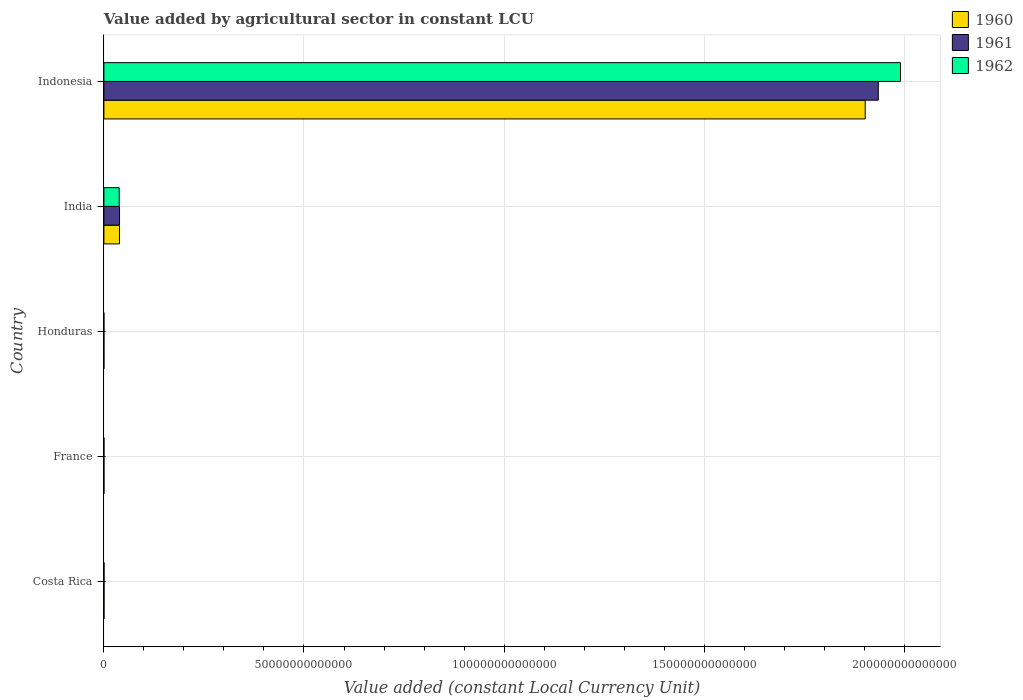How many different coloured bars are there?
Keep it short and to the point. 3. How many groups of bars are there?
Offer a very short reply. 5. Are the number of bars on each tick of the Y-axis equal?
Your response must be concise. Yes. How many bars are there on the 2nd tick from the bottom?
Provide a succinct answer. 3. What is the value added by agricultural sector in 1962 in Honduras?
Provide a short and direct response. 4.96e+09. Across all countries, what is the maximum value added by agricultural sector in 1962?
Keep it short and to the point. 1.99e+14. Across all countries, what is the minimum value added by agricultural sector in 1962?
Your answer should be compact. 4.96e+09. In which country was the value added by agricultural sector in 1960 maximum?
Give a very brief answer. Indonesia. In which country was the value added by agricultural sector in 1961 minimum?
Offer a terse response. Honduras. What is the total value added by agricultural sector in 1960 in the graph?
Your answer should be compact. 1.94e+14. What is the difference between the value added by agricultural sector in 1960 in Costa Rica and that in France?
Provide a succinct answer. 1.92e+1. What is the difference between the value added by agricultural sector in 1961 in India and the value added by agricultural sector in 1960 in France?
Offer a terse response. 3.89e+12. What is the average value added by agricultural sector in 1962 per country?
Give a very brief answer. 4.06e+13. What is the difference between the value added by agricultural sector in 1961 and value added by agricultural sector in 1962 in Honduras?
Offer a very short reply. -2.25e+08. In how many countries, is the value added by agricultural sector in 1960 greater than 50000000000000 LCU?
Ensure brevity in your answer.  1. What is the ratio of the value added by agricultural sector in 1961 in Costa Rica to that in Indonesia?
Offer a terse response. 0. Is the difference between the value added by agricultural sector in 1961 in France and Indonesia greater than the difference between the value added by agricultural sector in 1962 in France and Indonesia?
Make the answer very short. Yes. What is the difference between the highest and the second highest value added by agricultural sector in 1962?
Your response must be concise. 1.95e+14. What is the difference between the highest and the lowest value added by agricultural sector in 1962?
Ensure brevity in your answer.  1.99e+14. Is it the case that in every country, the sum of the value added by agricultural sector in 1961 and value added by agricultural sector in 1962 is greater than the value added by agricultural sector in 1960?
Your response must be concise. Yes. How many bars are there?
Your answer should be very brief. 15. Are all the bars in the graph horizontal?
Ensure brevity in your answer.  Yes. What is the difference between two consecutive major ticks on the X-axis?
Offer a very short reply. 5.00e+13. Does the graph contain any zero values?
Provide a succinct answer. No. Does the graph contain grids?
Your answer should be compact. Yes. Where does the legend appear in the graph?
Provide a succinct answer. Top right. How many legend labels are there?
Provide a succinct answer. 3. What is the title of the graph?
Your answer should be compact. Value added by agricultural sector in constant LCU. Does "1998" appear as one of the legend labels in the graph?
Your answer should be compact. No. What is the label or title of the X-axis?
Ensure brevity in your answer.  Value added (constant Local Currency Unit). What is the label or title of the Y-axis?
Keep it short and to the point. Country. What is the Value added (constant Local Currency Unit) of 1960 in Costa Rica?
Your answer should be very brief. 3.24e+1. What is the Value added (constant Local Currency Unit) in 1961 in Costa Rica?
Your answer should be very brief. 3.36e+1. What is the Value added (constant Local Currency Unit) of 1962 in Costa Rica?
Offer a terse response. 3.57e+1. What is the Value added (constant Local Currency Unit) of 1960 in France?
Provide a succinct answer. 1.32e+1. What is the Value added (constant Local Currency Unit) in 1961 in France?
Your response must be concise. 1.25e+1. What is the Value added (constant Local Currency Unit) in 1962 in France?
Offer a very short reply. 1.36e+1. What is the Value added (constant Local Currency Unit) in 1960 in Honduras?
Provide a succinct answer. 4.44e+09. What is the Value added (constant Local Currency Unit) in 1961 in Honduras?
Ensure brevity in your answer.  4.73e+09. What is the Value added (constant Local Currency Unit) in 1962 in Honduras?
Ensure brevity in your answer.  4.96e+09. What is the Value added (constant Local Currency Unit) of 1960 in India?
Give a very brief answer. 3.90e+12. What is the Value added (constant Local Currency Unit) of 1961 in India?
Your answer should be compact. 3.91e+12. What is the Value added (constant Local Currency Unit) of 1962 in India?
Offer a very short reply. 3.83e+12. What is the Value added (constant Local Currency Unit) of 1960 in Indonesia?
Keep it short and to the point. 1.90e+14. What is the Value added (constant Local Currency Unit) in 1961 in Indonesia?
Ensure brevity in your answer.  1.94e+14. What is the Value added (constant Local Currency Unit) of 1962 in Indonesia?
Your answer should be compact. 1.99e+14. Across all countries, what is the maximum Value added (constant Local Currency Unit) of 1960?
Offer a very short reply. 1.90e+14. Across all countries, what is the maximum Value added (constant Local Currency Unit) of 1961?
Offer a very short reply. 1.94e+14. Across all countries, what is the maximum Value added (constant Local Currency Unit) of 1962?
Keep it short and to the point. 1.99e+14. Across all countries, what is the minimum Value added (constant Local Currency Unit) in 1960?
Your response must be concise. 4.44e+09. Across all countries, what is the minimum Value added (constant Local Currency Unit) of 1961?
Keep it short and to the point. 4.73e+09. Across all countries, what is the minimum Value added (constant Local Currency Unit) of 1962?
Your answer should be very brief. 4.96e+09. What is the total Value added (constant Local Currency Unit) of 1960 in the graph?
Provide a short and direct response. 1.94e+14. What is the total Value added (constant Local Currency Unit) of 1961 in the graph?
Offer a very short reply. 1.97e+14. What is the total Value added (constant Local Currency Unit) in 1962 in the graph?
Provide a succinct answer. 2.03e+14. What is the difference between the Value added (constant Local Currency Unit) of 1960 in Costa Rica and that in France?
Give a very brief answer. 1.92e+1. What is the difference between the Value added (constant Local Currency Unit) of 1961 in Costa Rica and that in France?
Offer a very short reply. 2.11e+1. What is the difference between the Value added (constant Local Currency Unit) in 1962 in Costa Rica and that in France?
Your response must be concise. 2.21e+1. What is the difference between the Value added (constant Local Currency Unit) of 1960 in Costa Rica and that in Honduras?
Your response must be concise. 2.80e+1. What is the difference between the Value added (constant Local Currency Unit) in 1961 in Costa Rica and that in Honduras?
Provide a succinct answer. 2.89e+1. What is the difference between the Value added (constant Local Currency Unit) of 1962 in Costa Rica and that in Honduras?
Give a very brief answer. 3.07e+1. What is the difference between the Value added (constant Local Currency Unit) in 1960 in Costa Rica and that in India?
Make the answer very short. -3.87e+12. What is the difference between the Value added (constant Local Currency Unit) of 1961 in Costa Rica and that in India?
Ensure brevity in your answer.  -3.87e+12. What is the difference between the Value added (constant Local Currency Unit) in 1962 in Costa Rica and that in India?
Your answer should be very brief. -3.79e+12. What is the difference between the Value added (constant Local Currency Unit) of 1960 in Costa Rica and that in Indonesia?
Keep it short and to the point. -1.90e+14. What is the difference between the Value added (constant Local Currency Unit) of 1961 in Costa Rica and that in Indonesia?
Your response must be concise. -1.93e+14. What is the difference between the Value added (constant Local Currency Unit) in 1962 in Costa Rica and that in Indonesia?
Provide a short and direct response. -1.99e+14. What is the difference between the Value added (constant Local Currency Unit) in 1960 in France and that in Honduras?
Your answer should be compact. 8.72e+09. What is the difference between the Value added (constant Local Currency Unit) in 1961 in France and that in Honduras?
Provide a succinct answer. 7.74e+09. What is the difference between the Value added (constant Local Currency Unit) in 1962 in France and that in Honduras?
Your response must be concise. 8.63e+09. What is the difference between the Value added (constant Local Currency Unit) of 1960 in France and that in India?
Ensure brevity in your answer.  -3.89e+12. What is the difference between the Value added (constant Local Currency Unit) of 1961 in France and that in India?
Your answer should be very brief. -3.90e+12. What is the difference between the Value added (constant Local Currency Unit) in 1962 in France and that in India?
Your answer should be compact. -3.82e+12. What is the difference between the Value added (constant Local Currency Unit) in 1960 in France and that in Indonesia?
Keep it short and to the point. -1.90e+14. What is the difference between the Value added (constant Local Currency Unit) in 1961 in France and that in Indonesia?
Your answer should be compact. -1.94e+14. What is the difference between the Value added (constant Local Currency Unit) in 1962 in France and that in Indonesia?
Give a very brief answer. -1.99e+14. What is the difference between the Value added (constant Local Currency Unit) of 1960 in Honduras and that in India?
Your response must be concise. -3.90e+12. What is the difference between the Value added (constant Local Currency Unit) of 1961 in Honduras and that in India?
Your answer should be very brief. -3.90e+12. What is the difference between the Value added (constant Local Currency Unit) of 1962 in Honduras and that in India?
Your answer should be very brief. -3.82e+12. What is the difference between the Value added (constant Local Currency Unit) in 1960 in Honduras and that in Indonesia?
Offer a very short reply. -1.90e+14. What is the difference between the Value added (constant Local Currency Unit) in 1961 in Honduras and that in Indonesia?
Offer a very short reply. -1.94e+14. What is the difference between the Value added (constant Local Currency Unit) of 1962 in Honduras and that in Indonesia?
Provide a succinct answer. -1.99e+14. What is the difference between the Value added (constant Local Currency Unit) in 1960 in India and that in Indonesia?
Your answer should be compact. -1.86e+14. What is the difference between the Value added (constant Local Currency Unit) of 1961 in India and that in Indonesia?
Offer a terse response. -1.90e+14. What is the difference between the Value added (constant Local Currency Unit) of 1962 in India and that in Indonesia?
Ensure brevity in your answer.  -1.95e+14. What is the difference between the Value added (constant Local Currency Unit) of 1960 in Costa Rica and the Value added (constant Local Currency Unit) of 1961 in France?
Make the answer very short. 1.99e+1. What is the difference between the Value added (constant Local Currency Unit) of 1960 in Costa Rica and the Value added (constant Local Currency Unit) of 1962 in France?
Offer a terse response. 1.88e+1. What is the difference between the Value added (constant Local Currency Unit) of 1961 in Costa Rica and the Value added (constant Local Currency Unit) of 1962 in France?
Your answer should be compact. 2.00e+1. What is the difference between the Value added (constant Local Currency Unit) in 1960 in Costa Rica and the Value added (constant Local Currency Unit) in 1961 in Honduras?
Provide a short and direct response. 2.77e+1. What is the difference between the Value added (constant Local Currency Unit) in 1960 in Costa Rica and the Value added (constant Local Currency Unit) in 1962 in Honduras?
Make the answer very short. 2.74e+1. What is the difference between the Value added (constant Local Currency Unit) in 1961 in Costa Rica and the Value added (constant Local Currency Unit) in 1962 in Honduras?
Provide a succinct answer. 2.86e+1. What is the difference between the Value added (constant Local Currency Unit) in 1960 in Costa Rica and the Value added (constant Local Currency Unit) in 1961 in India?
Provide a short and direct response. -3.88e+12. What is the difference between the Value added (constant Local Currency Unit) in 1960 in Costa Rica and the Value added (constant Local Currency Unit) in 1962 in India?
Offer a terse response. -3.80e+12. What is the difference between the Value added (constant Local Currency Unit) in 1961 in Costa Rica and the Value added (constant Local Currency Unit) in 1962 in India?
Give a very brief answer. -3.80e+12. What is the difference between the Value added (constant Local Currency Unit) in 1960 in Costa Rica and the Value added (constant Local Currency Unit) in 1961 in Indonesia?
Ensure brevity in your answer.  -1.93e+14. What is the difference between the Value added (constant Local Currency Unit) in 1960 in Costa Rica and the Value added (constant Local Currency Unit) in 1962 in Indonesia?
Ensure brevity in your answer.  -1.99e+14. What is the difference between the Value added (constant Local Currency Unit) of 1961 in Costa Rica and the Value added (constant Local Currency Unit) of 1962 in Indonesia?
Offer a terse response. -1.99e+14. What is the difference between the Value added (constant Local Currency Unit) of 1960 in France and the Value added (constant Local Currency Unit) of 1961 in Honduras?
Make the answer very short. 8.43e+09. What is the difference between the Value added (constant Local Currency Unit) in 1960 in France and the Value added (constant Local Currency Unit) in 1962 in Honduras?
Ensure brevity in your answer.  8.20e+09. What is the difference between the Value added (constant Local Currency Unit) in 1961 in France and the Value added (constant Local Currency Unit) in 1962 in Honduras?
Your answer should be very brief. 7.52e+09. What is the difference between the Value added (constant Local Currency Unit) in 1960 in France and the Value added (constant Local Currency Unit) in 1961 in India?
Keep it short and to the point. -3.89e+12. What is the difference between the Value added (constant Local Currency Unit) of 1960 in France and the Value added (constant Local Currency Unit) of 1962 in India?
Offer a terse response. -3.82e+12. What is the difference between the Value added (constant Local Currency Unit) of 1961 in France and the Value added (constant Local Currency Unit) of 1962 in India?
Provide a short and direct response. -3.82e+12. What is the difference between the Value added (constant Local Currency Unit) of 1960 in France and the Value added (constant Local Currency Unit) of 1961 in Indonesia?
Your response must be concise. -1.94e+14. What is the difference between the Value added (constant Local Currency Unit) of 1960 in France and the Value added (constant Local Currency Unit) of 1962 in Indonesia?
Keep it short and to the point. -1.99e+14. What is the difference between the Value added (constant Local Currency Unit) of 1961 in France and the Value added (constant Local Currency Unit) of 1962 in Indonesia?
Your response must be concise. -1.99e+14. What is the difference between the Value added (constant Local Currency Unit) of 1960 in Honduras and the Value added (constant Local Currency Unit) of 1961 in India?
Your answer should be very brief. -3.90e+12. What is the difference between the Value added (constant Local Currency Unit) of 1960 in Honduras and the Value added (constant Local Currency Unit) of 1962 in India?
Keep it short and to the point. -3.83e+12. What is the difference between the Value added (constant Local Currency Unit) of 1961 in Honduras and the Value added (constant Local Currency Unit) of 1962 in India?
Offer a terse response. -3.83e+12. What is the difference between the Value added (constant Local Currency Unit) of 1960 in Honduras and the Value added (constant Local Currency Unit) of 1961 in Indonesia?
Your response must be concise. -1.94e+14. What is the difference between the Value added (constant Local Currency Unit) in 1960 in Honduras and the Value added (constant Local Currency Unit) in 1962 in Indonesia?
Keep it short and to the point. -1.99e+14. What is the difference between the Value added (constant Local Currency Unit) of 1961 in Honduras and the Value added (constant Local Currency Unit) of 1962 in Indonesia?
Offer a very short reply. -1.99e+14. What is the difference between the Value added (constant Local Currency Unit) in 1960 in India and the Value added (constant Local Currency Unit) in 1961 in Indonesia?
Your answer should be very brief. -1.90e+14. What is the difference between the Value added (constant Local Currency Unit) in 1960 in India and the Value added (constant Local Currency Unit) in 1962 in Indonesia?
Offer a very short reply. -1.95e+14. What is the difference between the Value added (constant Local Currency Unit) of 1961 in India and the Value added (constant Local Currency Unit) of 1962 in Indonesia?
Offer a very short reply. -1.95e+14. What is the average Value added (constant Local Currency Unit) in 1960 per country?
Offer a terse response. 3.88e+13. What is the average Value added (constant Local Currency Unit) of 1961 per country?
Make the answer very short. 3.95e+13. What is the average Value added (constant Local Currency Unit) in 1962 per country?
Ensure brevity in your answer.  4.06e+13. What is the difference between the Value added (constant Local Currency Unit) in 1960 and Value added (constant Local Currency Unit) in 1961 in Costa Rica?
Provide a succinct answer. -1.19e+09. What is the difference between the Value added (constant Local Currency Unit) of 1960 and Value added (constant Local Currency Unit) of 1962 in Costa Rica?
Give a very brief answer. -3.25e+09. What is the difference between the Value added (constant Local Currency Unit) of 1961 and Value added (constant Local Currency Unit) of 1962 in Costa Rica?
Your answer should be very brief. -2.06e+09. What is the difference between the Value added (constant Local Currency Unit) in 1960 and Value added (constant Local Currency Unit) in 1961 in France?
Ensure brevity in your answer.  6.84e+08. What is the difference between the Value added (constant Local Currency Unit) of 1960 and Value added (constant Local Currency Unit) of 1962 in France?
Provide a short and direct response. -4.23e+08. What is the difference between the Value added (constant Local Currency Unit) of 1961 and Value added (constant Local Currency Unit) of 1962 in France?
Your answer should be compact. -1.11e+09. What is the difference between the Value added (constant Local Currency Unit) in 1960 and Value added (constant Local Currency Unit) in 1961 in Honduras?
Your answer should be compact. -2.90e+08. What is the difference between the Value added (constant Local Currency Unit) of 1960 and Value added (constant Local Currency Unit) of 1962 in Honduras?
Your response must be concise. -5.15e+08. What is the difference between the Value added (constant Local Currency Unit) in 1961 and Value added (constant Local Currency Unit) in 1962 in Honduras?
Ensure brevity in your answer.  -2.25e+08. What is the difference between the Value added (constant Local Currency Unit) in 1960 and Value added (constant Local Currency Unit) in 1961 in India?
Your answer should be very brief. -3.29e+09. What is the difference between the Value added (constant Local Currency Unit) in 1960 and Value added (constant Local Currency Unit) in 1962 in India?
Keep it short and to the point. 7.44e+1. What is the difference between the Value added (constant Local Currency Unit) of 1961 and Value added (constant Local Currency Unit) of 1962 in India?
Your answer should be very brief. 7.77e+1. What is the difference between the Value added (constant Local Currency Unit) of 1960 and Value added (constant Local Currency Unit) of 1961 in Indonesia?
Provide a short and direct response. -3.27e+12. What is the difference between the Value added (constant Local Currency Unit) in 1960 and Value added (constant Local Currency Unit) in 1962 in Indonesia?
Your answer should be compact. -8.83e+12. What is the difference between the Value added (constant Local Currency Unit) in 1961 and Value added (constant Local Currency Unit) in 1962 in Indonesia?
Provide a succinct answer. -5.56e+12. What is the ratio of the Value added (constant Local Currency Unit) of 1960 in Costa Rica to that in France?
Your answer should be very brief. 2.46. What is the ratio of the Value added (constant Local Currency Unit) of 1961 in Costa Rica to that in France?
Offer a very short reply. 2.69. What is the ratio of the Value added (constant Local Currency Unit) of 1962 in Costa Rica to that in France?
Your answer should be very brief. 2.63. What is the ratio of the Value added (constant Local Currency Unit) of 1960 in Costa Rica to that in Honduras?
Offer a very short reply. 7.3. What is the ratio of the Value added (constant Local Currency Unit) in 1961 in Costa Rica to that in Honduras?
Offer a terse response. 7.1. What is the ratio of the Value added (constant Local Currency Unit) in 1962 in Costa Rica to that in Honduras?
Provide a short and direct response. 7.2. What is the ratio of the Value added (constant Local Currency Unit) in 1960 in Costa Rica to that in India?
Your answer should be very brief. 0.01. What is the ratio of the Value added (constant Local Currency Unit) in 1961 in Costa Rica to that in India?
Give a very brief answer. 0.01. What is the ratio of the Value added (constant Local Currency Unit) in 1962 in Costa Rica to that in India?
Your response must be concise. 0.01. What is the ratio of the Value added (constant Local Currency Unit) of 1961 in Costa Rica to that in Indonesia?
Provide a succinct answer. 0. What is the ratio of the Value added (constant Local Currency Unit) of 1960 in France to that in Honduras?
Give a very brief answer. 2.96. What is the ratio of the Value added (constant Local Currency Unit) in 1961 in France to that in Honduras?
Your response must be concise. 2.64. What is the ratio of the Value added (constant Local Currency Unit) of 1962 in France to that in Honduras?
Offer a terse response. 2.74. What is the ratio of the Value added (constant Local Currency Unit) in 1960 in France to that in India?
Your answer should be very brief. 0. What is the ratio of the Value added (constant Local Currency Unit) in 1961 in France to that in India?
Make the answer very short. 0. What is the ratio of the Value added (constant Local Currency Unit) of 1962 in France to that in India?
Keep it short and to the point. 0. What is the ratio of the Value added (constant Local Currency Unit) of 1961 in France to that in Indonesia?
Your answer should be compact. 0. What is the ratio of the Value added (constant Local Currency Unit) in 1960 in Honduras to that in India?
Keep it short and to the point. 0. What is the ratio of the Value added (constant Local Currency Unit) of 1961 in Honduras to that in India?
Ensure brevity in your answer.  0. What is the ratio of the Value added (constant Local Currency Unit) in 1962 in Honduras to that in India?
Your answer should be compact. 0. What is the ratio of the Value added (constant Local Currency Unit) in 1961 in Honduras to that in Indonesia?
Offer a very short reply. 0. What is the ratio of the Value added (constant Local Currency Unit) of 1960 in India to that in Indonesia?
Your answer should be very brief. 0.02. What is the ratio of the Value added (constant Local Currency Unit) in 1961 in India to that in Indonesia?
Provide a succinct answer. 0.02. What is the ratio of the Value added (constant Local Currency Unit) in 1962 in India to that in Indonesia?
Your answer should be very brief. 0.02. What is the difference between the highest and the second highest Value added (constant Local Currency Unit) in 1960?
Provide a succinct answer. 1.86e+14. What is the difference between the highest and the second highest Value added (constant Local Currency Unit) of 1961?
Offer a terse response. 1.90e+14. What is the difference between the highest and the second highest Value added (constant Local Currency Unit) in 1962?
Your answer should be compact. 1.95e+14. What is the difference between the highest and the lowest Value added (constant Local Currency Unit) in 1960?
Your answer should be very brief. 1.90e+14. What is the difference between the highest and the lowest Value added (constant Local Currency Unit) in 1961?
Your answer should be very brief. 1.94e+14. What is the difference between the highest and the lowest Value added (constant Local Currency Unit) of 1962?
Your response must be concise. 1.99e+14. 